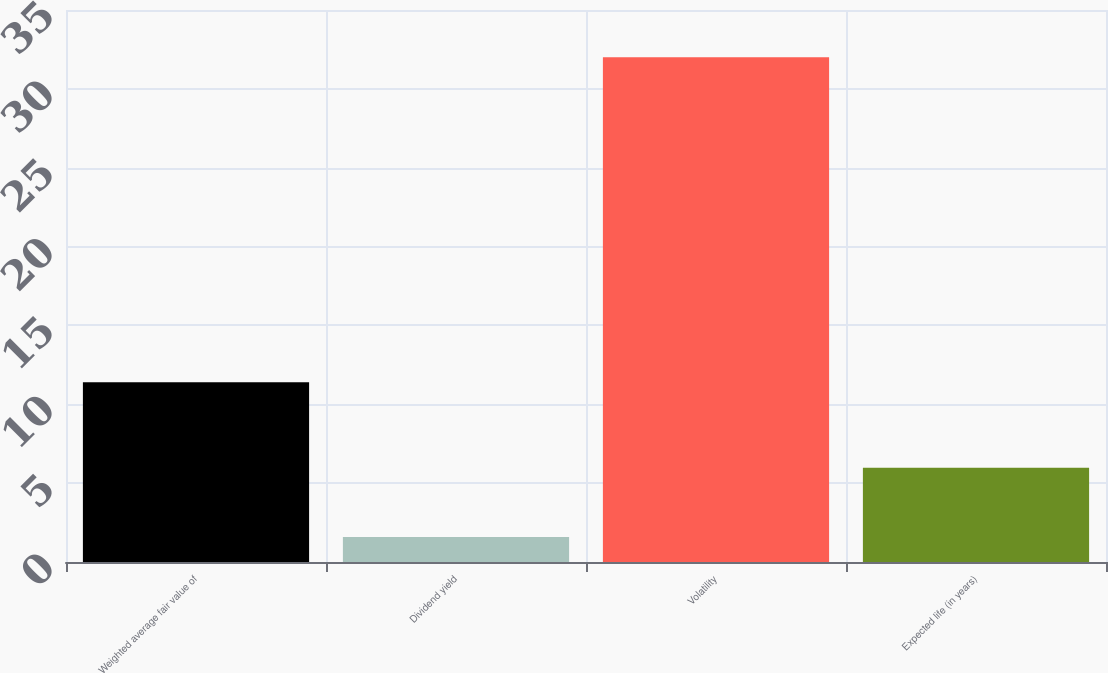Convert chart. <chart><loc_0><loc_0><loc_500><loc_500><bar_chart><fcel>Weighted average fair value of<fcel>Dividend yield<fcel>Volatility<fcel>Expected life (in years)<nl><fcel>11.4<fcel>1.59<fcel>32<fcel>5.98<nl></chart> 